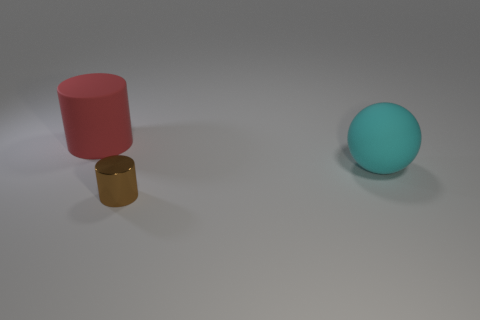Add 3 tiny yellow rubber cylinders. How many objects exist? 6 Subtract all brown cylinders. How many cylinders are left? 1 Subtract all cylinders. How many objects are left? 1 Subtract all brown cylinders. Subtract all purple blocks. How many cylinders are left? 1 Subtract all red balls. How many purple cylinders are left? 0 Subtract all big red objects. Subtract all cyan balls. How many objects are left? 1 Add 3 brown shiny objects. How many brown shiny objects are left? 4 Add 2 tiny cyan shiny cylinders. How many tiny cyan shiny cylinders exist? 2 Subtract 0 green spheres. How many objects are left? 3 Subtract 1 cylinders. How many cylinders are left? 1 